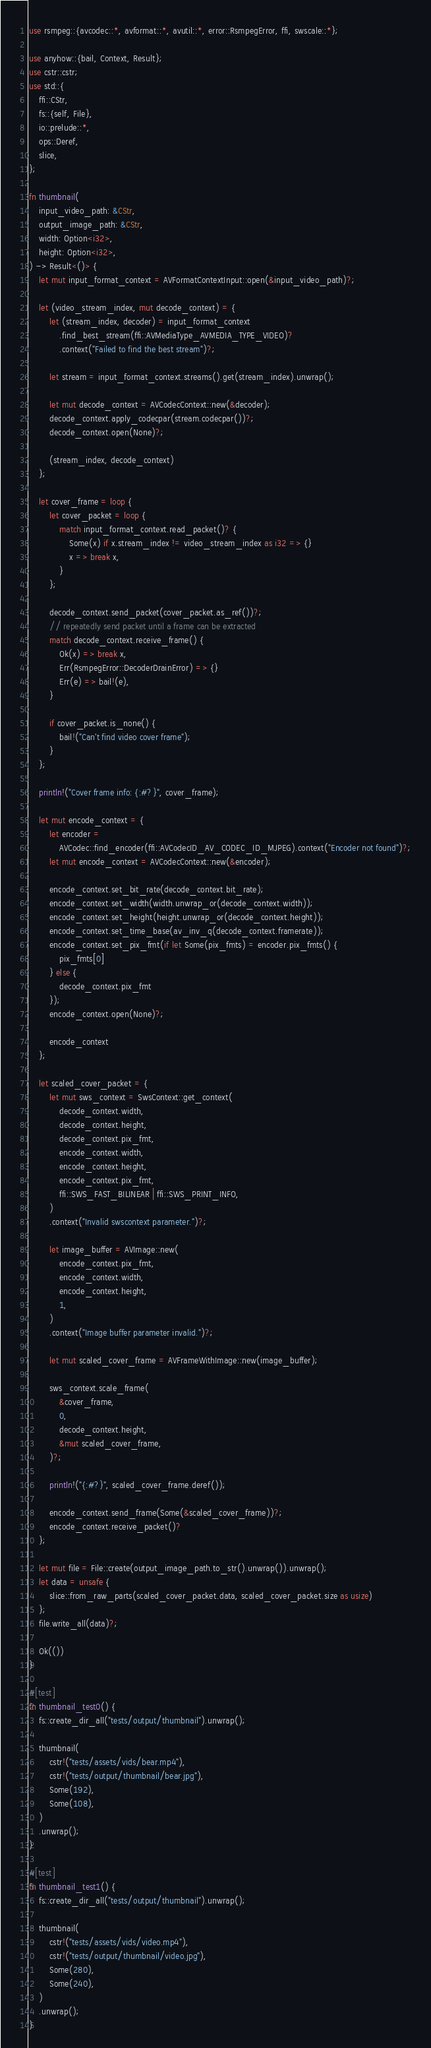Convert code to text. <code><loc_0><loc_0><loc_500><loc_500><_Rust_>use rsmpeg::{avcodec::*, avformat::*, avutil::*, error::RsmpegError, ffi, swscale::*};

use anyhow::{bail, Context, Result};
use cstr::cstr;
use std::{
    ffi::CStr,
    fs::{self, File},
    io::prelude::*,
    ops::Deref,
    slice,
};

fn thumbnail(
    input_video_path: &CStr,
    output_image_path: &CStr,
    width: Option<i32>,
    height: Option<i32>,
) -> Result<()> {
    let mut input_format_context = AVFormatContextInput::open(&input_video_path)?;

    let (video_stream_index, mut decode_context) = {
        let (stream_index, decoder) = input_format_context
            .find_best_stream(ffi::AVMediaType_AVMEDIA_TYPE_VIDEO)?
            .context("Failed to find the best stream")?;

        let stream = input_format_context.streams().get(stream_index).unwrap();

        let mut decode_context = AVCodecContext::new(&decoder);
        decode_context.apply_codecpar(stream.codecpar())?;
        decode_context.open(None)?;

        (stream_index, decode_context)
    };

    let cover_frame = loop {
        let cover_packet = loop {
            match input_format_context.read_packet()? {
                Some(x) if x.stream_index != video_stream_index as i32 => {}
                x => break x,
            }
        };

        decode_context.send_packet(cover_packet.as_ref())?;
        // repeatedly send packet until a frame can be extracted
        match decode_context.receive_frame() {
            Ok(x) => break x,
            Err(RsmpegError::DecoderDrainError) => {}
            Err(e) => bail!(e),
        }

        if cover_packet.is_none() {
            bail!("Can't find video cover frame");
        }
    };

    println!("Cover frame info: {:#?}", cover_frame);

    let mut encode_context = {
        let encoder =
            AVCodec::find_encoder(ffi::AVCodecID_AV_CODEC_ID_MJPEG).context("Encoder not found")?;
        let mut encode_context = AVCodecContext::new(&encoder);

        encode_context.set_bit_rate(decode_context.bit_rate);
        encode_context.set_width(width.unwrap_or(decode_context.width));
        encode_context.set_height(height.unwrap_or(decode_context.height));
        encode_context.set_time_base(av_inv_q(decode_context.framerate));
        encode_context.set_pix_fmt(if let Some(pix_fmts) = encoder.pix_fmts() {
            pix_fmts[0]
        } else {
            decode_context.pix_fmt
        });
        encode_context.open(None)?;

        encode_context
    };

    let scaled_cover_packet = {
        let mut sws_context = SwsContext::get_context(
            decode_context.width,
            decode_context.height,
            decode_context.pix_fmt,
            encode_context.width,
            encode_context.height,
            encode_context.pix_fmt,
            ffi::SWS_FAST_BILINEAR | ffi::SWS_PRINT_INFO,
        )
        .context("Invalid swscontext parameter.")?;

        let image_buffer = AVImage::new(
            encode_context.pix_fmt,
            encode_context.width,
            encode_context.height,
            1,
        )
        .context("Image buffer parameter invalid.")?;

        let mut scaled_cover_frame = AVFrameWithImage::new(image_buffer);

        sws_context.scale_frame(
            &cover_frame,
            0,
            decode_context.height,
            &mut scaled_cover_frame,
        )?;

        println!("{:#?}", scaled_cover_frame.deref());

        encode_context.send_frame(Some(&scaled_cover_frame))?;
        encode_context.receive_packet()?
    };

    let mut file = File::create(output_image_path.to_str().unwrap()).unwrap();
    let data = unsafe {
        slice::from_raw_parts(scaled_cover_packet.data, scaled_cover_packet.size as usize)
    };
    file.write_all(data)?;

    Ok(())
}

#[test]
fn thumbnail_test0() {
    fs::create_dir_all("tests/output/thumbnail").unwrap();

    thumbnail(
        cstr!("tests/assets/vids/bear.mp4"),
        cstr!("tests/output/thumbnail/bear.jpg"),
        Some(192),
        Some(108),
    )
    .unwrap();
}

#[test]
fn thumbnail_test1() {
    fs::create_dir_all("tests/output/thumbnail").unwrap();

    thumbnail(
        cstr!("tests/assets/vids/video.mp4"),
        cstr!("tests/output/thumbnail/video.jpg"),
        Some(280),
        Some(240),
    )
    .unwrap();
}
</code> 